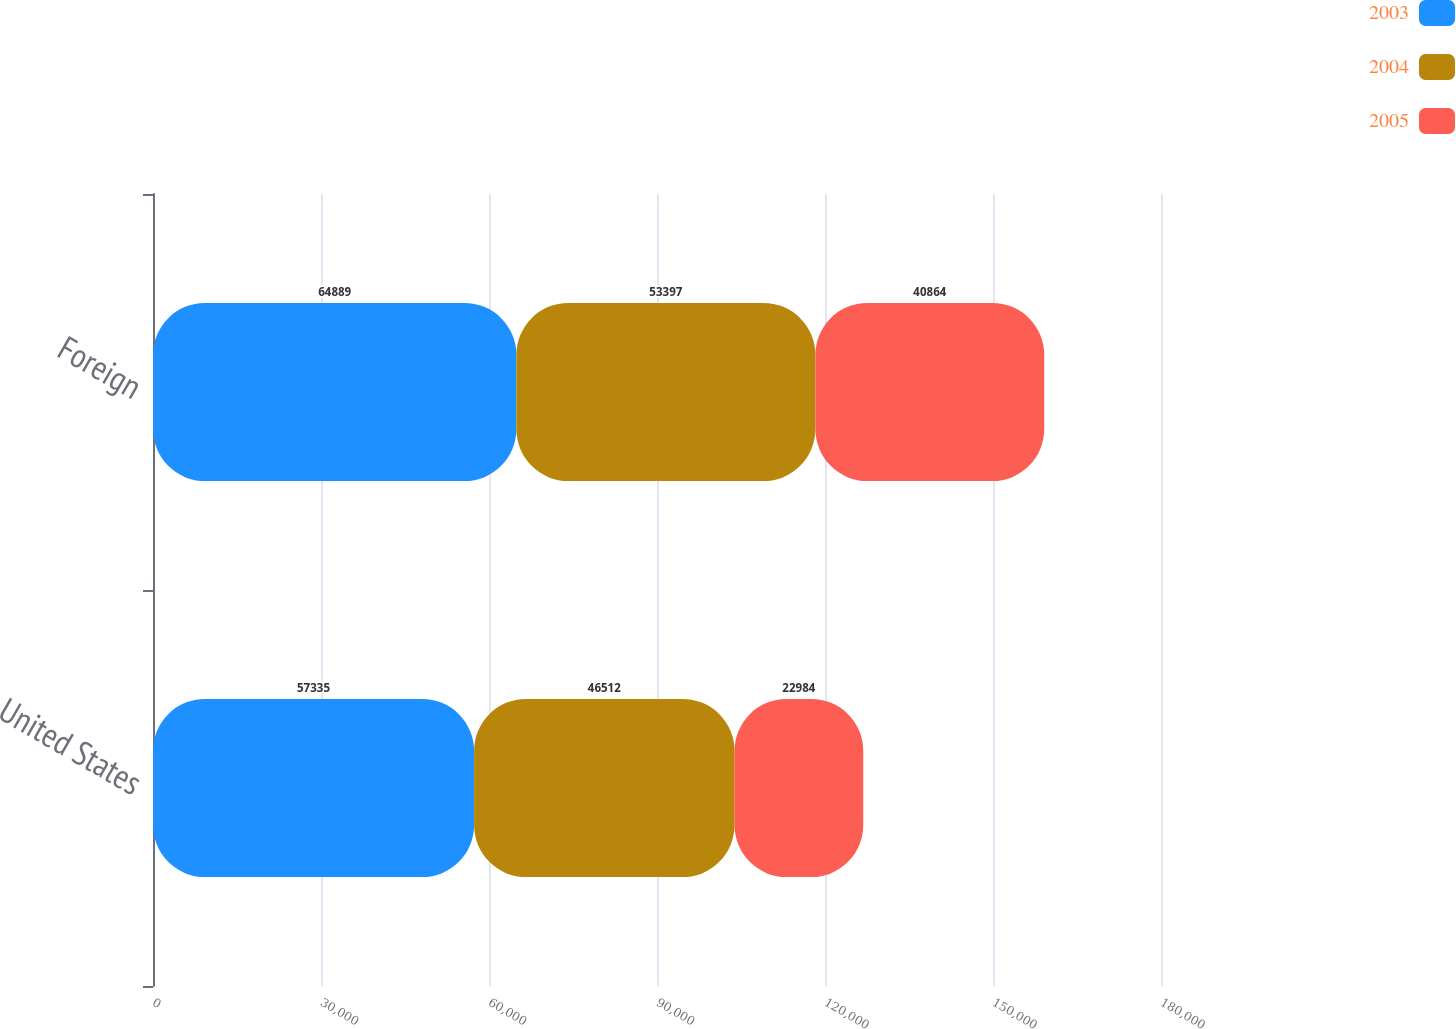Convert chart to OTSL. <chart><loc_0><loc_0><loc_500><loc_500><stacked_bar_chart><ecel><fcel>United States<fcel>Foreign<nl><fcel>2003<fcel>57335<fcel>64889<nl><fcel>2004<fcel>46512<fcel>53397<nl><fcel>2005<fcel>22984<fcel>40864<nl></chart> 